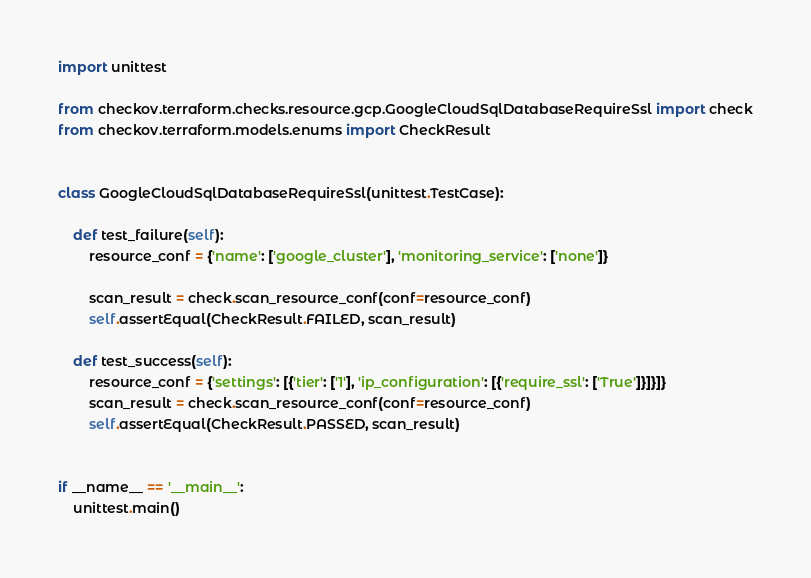Convert code to text. <code><loc_0><loc_0><loc_500><loc_500><_Python_>import unittest

from checkov.terraform.checks.resource.gcp.GoogleCloudSqlDatabaseRequireSsl import check
from checkov.terraform.models.enums import CheckResult


class GoogleCloudSqlDatabaseRequireSsl(unittest.TestCase):

    def test_failure(self):
        resource_conf = {'name': ['google_cluster'], 'monitoring_service': ['none']}

        scan_result = check.scan_resource_conf(conf=resource_conf)
        self.assertEqual(CheckResult.FAILED, scan_result)

    def test_success(self):
        resource_conf = {'settings': [{'tier': ['1'], 'ip_configuration': [{'require_ssl': ['True']}]}]}
        scan_result = check.scan_resource_conf(conf=resource_conf)
        self.assertEqual(CheckResult.PASSED, scan_result)


if __name__ == '__main__':
    unittest.main()
</code> 